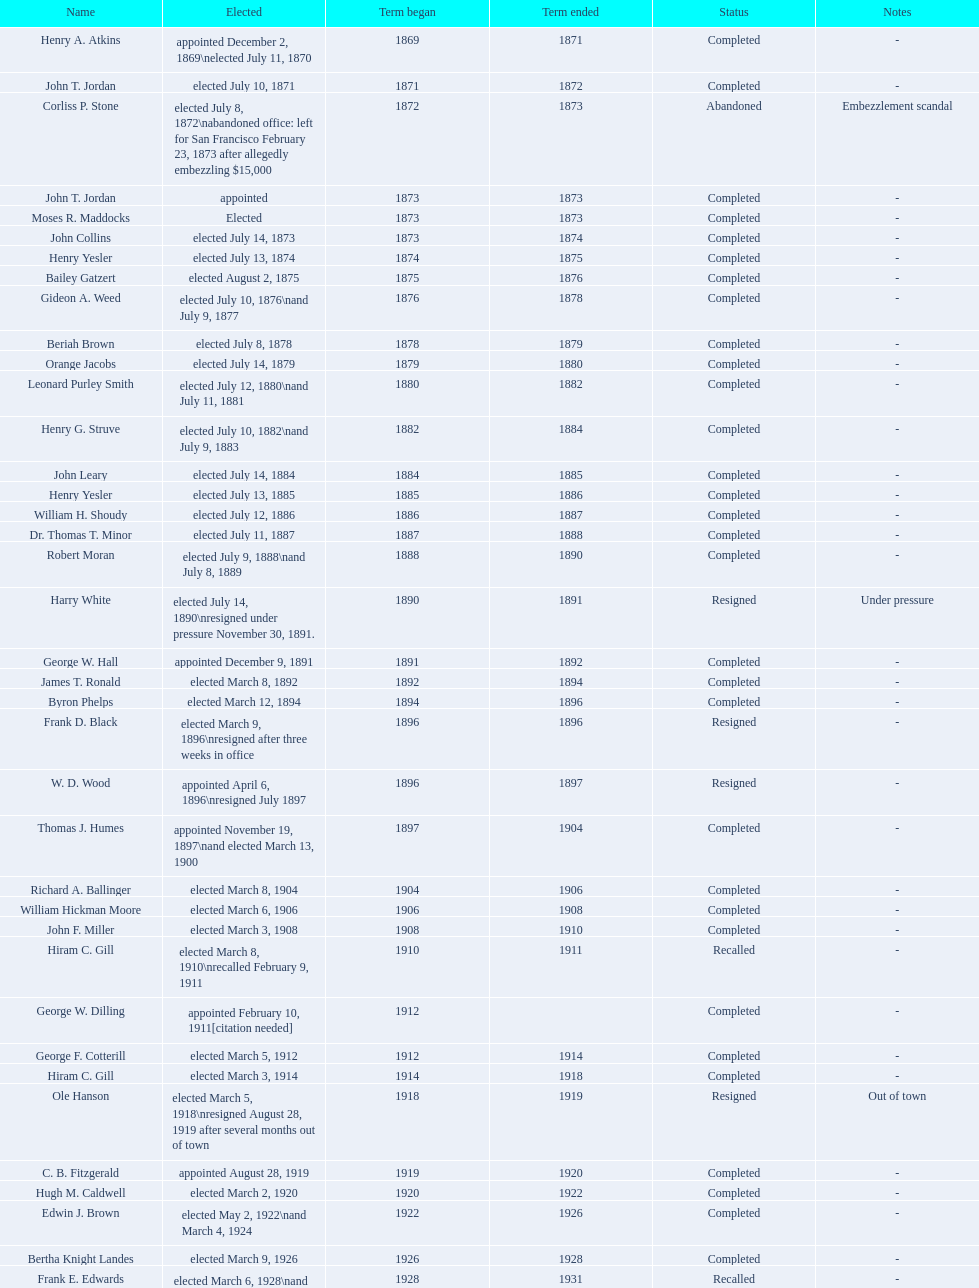Who occupied the role of mayor in seattle, washington before being designated to the department of transportation in the nixon administration? James d'Orma Braman. 